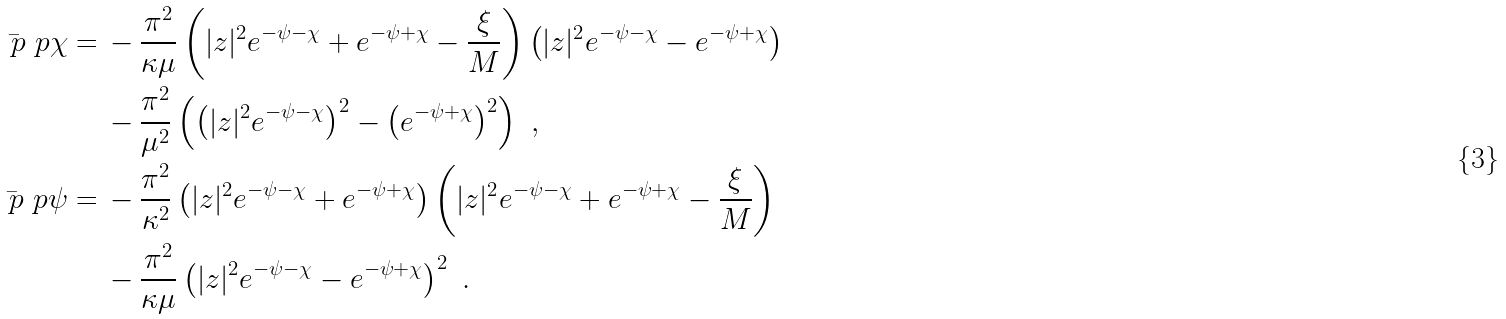Convert formula to latex. <formula><loc_0><loc_0><loc_500><loc_500>\bar { \ p } \ p \chi = & \, - \frac { \pi ^ { 2 } } { \kappa \mu } \left ( | z | ^ { 2 } e ^ { - \psi - \chi } + e ^ { - \psi + \chi } - \frac { \xi } { M } \right ) \left ( | z | ^ { 2 } e ^ { - \psi - \chi } - e ^ { - \psi + \chi } \right ) \\ & \, - \frac { \pi ^ { 2 } } { \mu ^ { 2 } } \left ( \left ( | z | ^ { 2 } e ^ { - \psi - \chi } \right ) ^ { 2 } - \left ( e ^ { - \psi + \chi } \right ) ^ { 2 } \right ) \ , \\ \bar { \ p } \ p \psi = & \, - \frac { \pi ^ { 2 } } { \kappa ^ { 2 } } \left ( | z | ^ { 2 } e ^ { - \psi - \chi } + e ^ { - \psi + \chi } \right ) \left ( | z | ^ { 2 } e ^ { - \psi - \chi } + e ^ { - \psi + \chi } - \frac { \xi } { M } \right ) \\ & \, - \frac { \pi ^ { 2 } } { \kappa \mu } \left ( | z | ^ { 2 } e ^ { - \psi - \chi } - e ^ { - \psi + \chi } \right ) ^ { 2 } \ .</formula> 